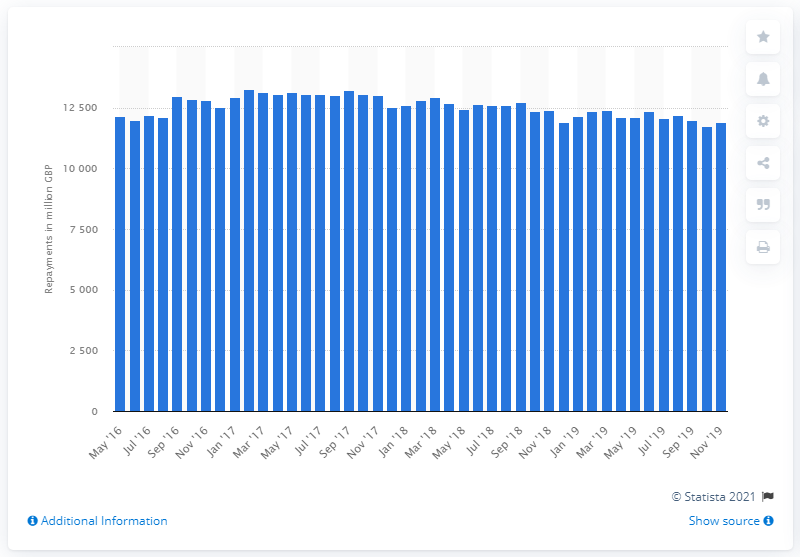Outline some significant characteristics in this image. As of November 2019, the value of outstanding overdrafts was 11,908. In February 2017, the total amount of outstanding overdrafts for small and medium enterprises was 13,238. 